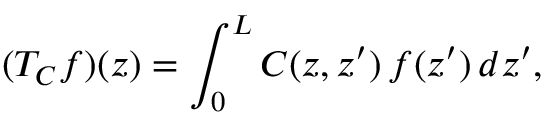Convert formula to latex. <formula><loc_0><loc_0><loc_500><loc_500>( T _ { C } f ) ( z ) = \int _ { 0 } ^ { L } C ( z , z ^ { \prime } ) \, f ( z ^ { \prime } ) \, d z ^ { \prime } ,</formula> 